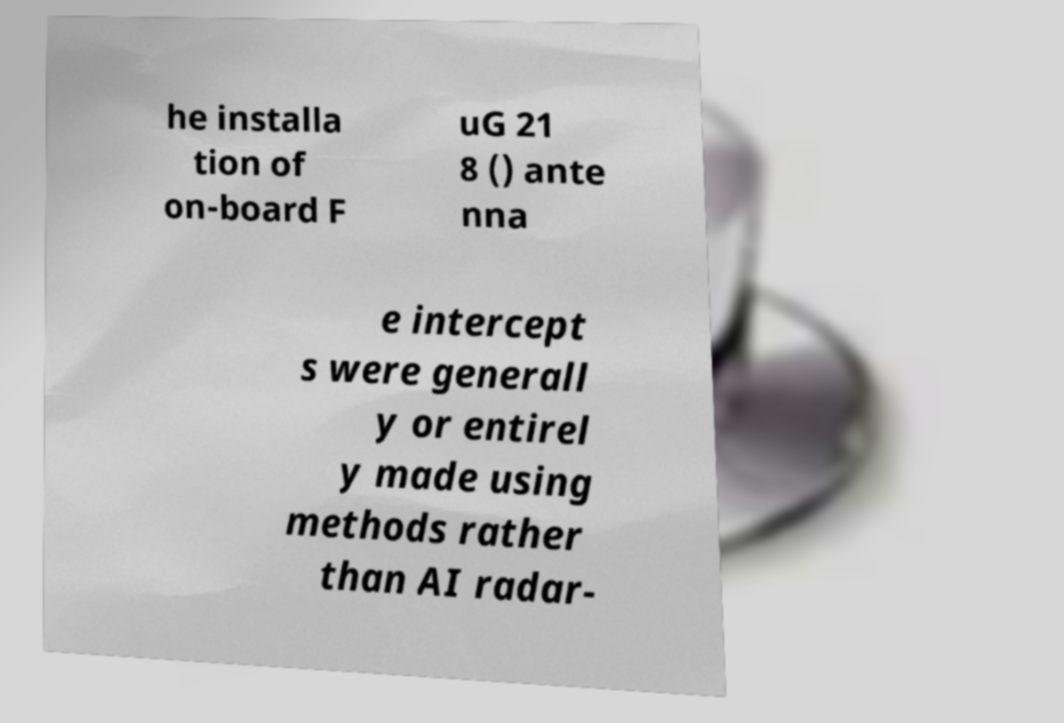For documentation purposes, I need the text within this image transcribed. Could you provide that? he installa tion of on-board F uG 21 8 () ante nna e intercept s were generall y or entirel y made using methods rather than AI radar- 